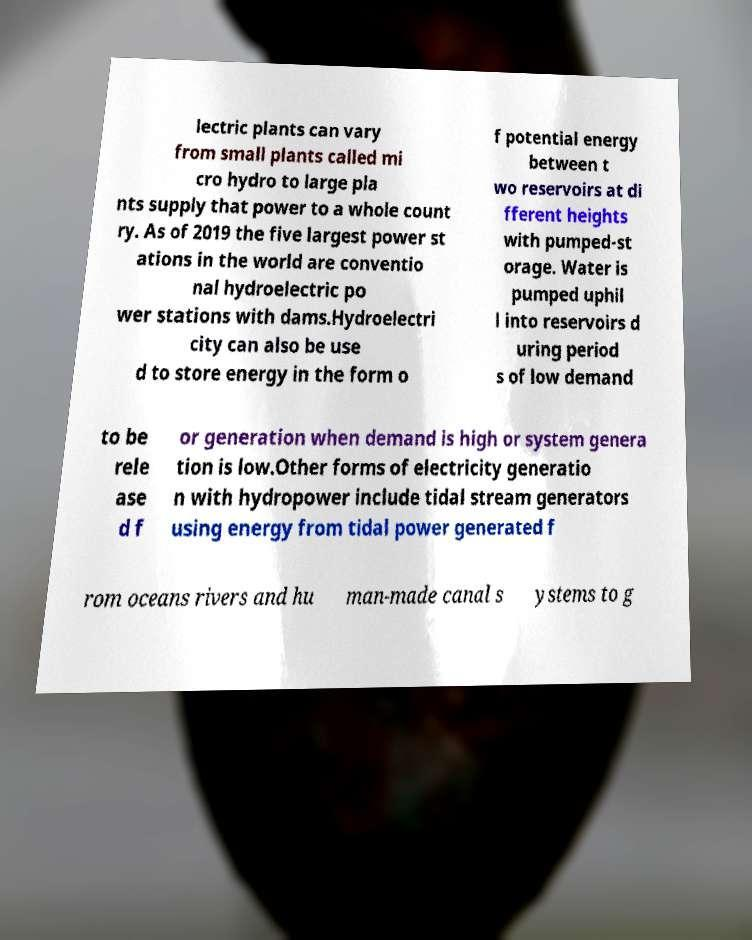Could you assist in decoding the text presented in this image and type it out clearly? lectric plants can vary from small plants called mi cro hydro to large pla nts supply that power to a whole count ry. As of 2019 the five largest power st ations in the world are conventio nal hydroelectric po wer stations with dams.Hydroelectri city can also be use d to store energy in the form o f potential energy between t wo reservoirs at di fferent heights with pumped-st orage. Water is pumped uphil l into reservoirs d uring period s of low demand to be rele ase d f or generation when demand is high or system genera tion is low.Other forms of electricity generatio n with hydropower include tidal stream generators using energy from tidal power generated f rom oceans rivers and hu man-made canal s ystems to g 